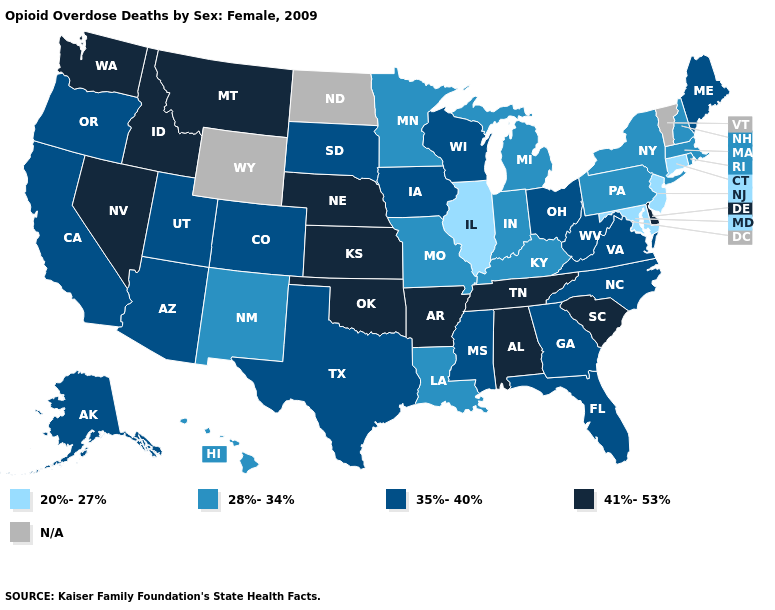What is the value of Minnesota?
Be succinct. 28%-34%. What is the highest value in states that border Nevada?
Short answer required. 41%-53%. Does North Carolina have the highest value in the South?
Short answer required. No. What is the value of Tennessee?
Answer briefly. 41%-53%. Name the states that have a value in the range 20%-27%?
Short answer required. Connecticut, Illinois, Maryland, New Jersey. Which states have the lowest value in the South?
Concise answer only. Maryland. What is the value of Massachusetts?
Quick response, please. 28%-34%. What is the value of Virginia?
Give a very brief answer. 35%-40%. Name the states that have a value in the range N/A?
Concise answer only. North Dakota, Vermont, Wyoming. What is the highest value in states that border California?
Keep it brief. 41%-53%. What is the highest value in the USA?
Give a very brief answer. 41%-53%. What is the highest value in the South ?
Quick response, please. 41%-53%. Name the states that have a value in the range 41%-53%?
Keep it brief. Alabama, Arkansas, Delaware, Idaho, Kansas, Montana, Nebraska, Nevada, Oklahoma, South Carolina, Tennessee, Washington. What is the value of Louisiana?
Answer briefly. 28%-34%. 